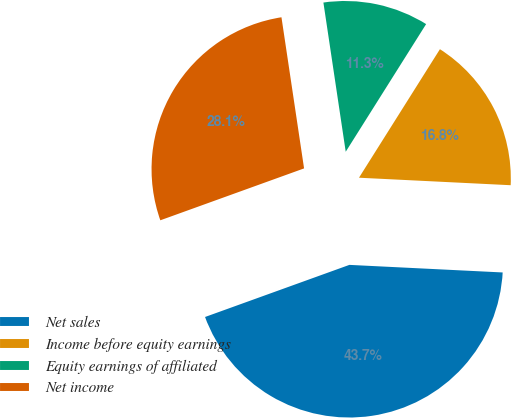<chart> <loc_0><loc_0><loc_500><loc_500><pie_chart><fcel>Net sales<fcel>Income before equity earnings<fcel>Equity earnings of affiliated<fcel>Net income<nl><fcel>43.7%<fcel>16.84%<fcel>11.31%<fcel>28.15%<nl></chart> 